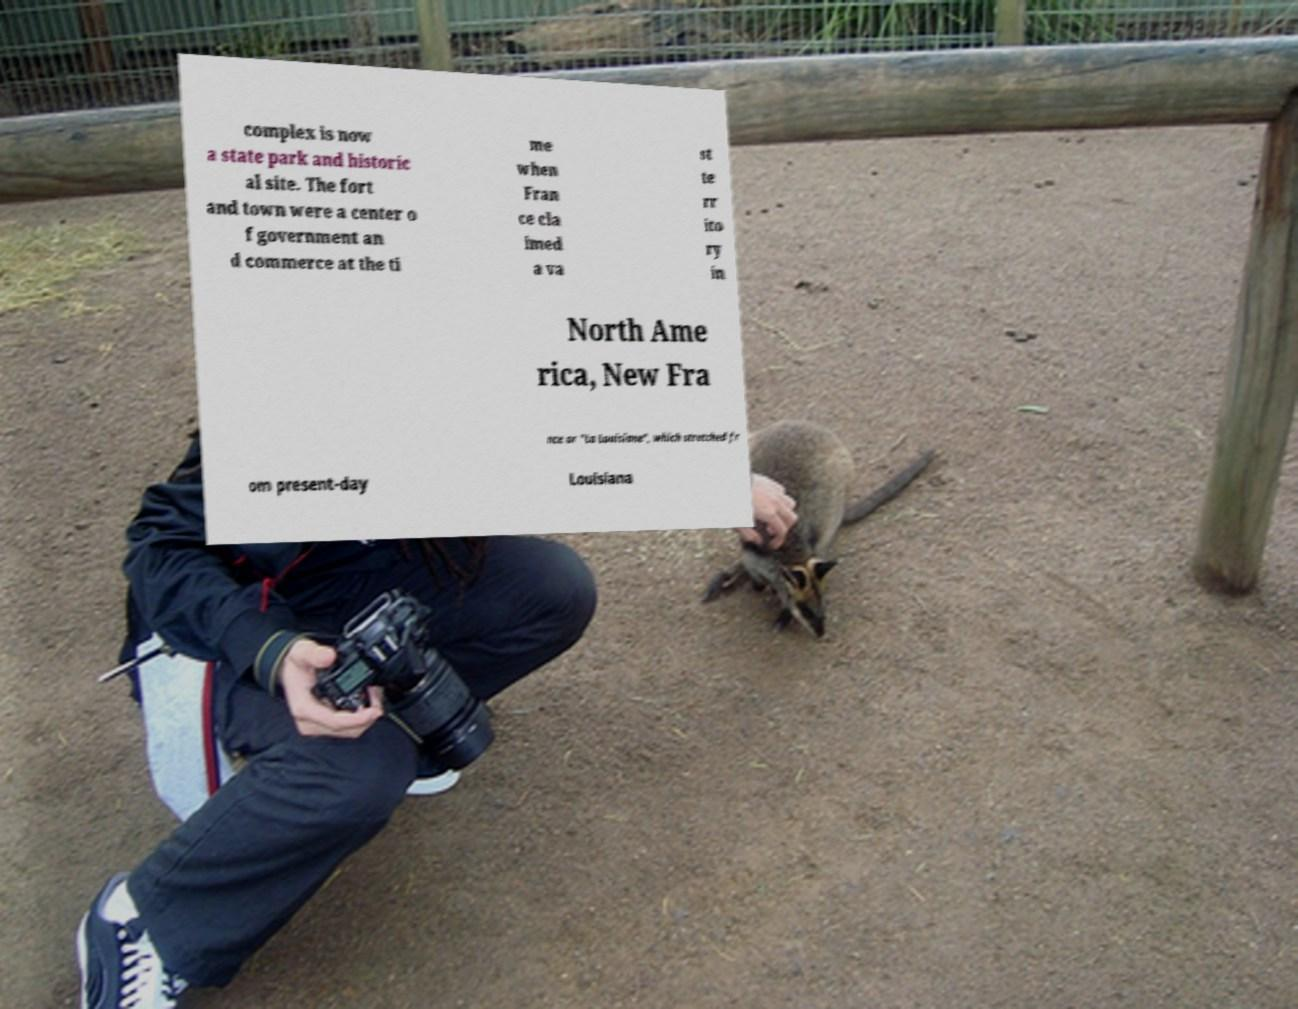Could you extract and type out the text from this image? complex is now a state park and historic al site. The fort and town were a center o f government an d commerce at the ti me when Fran ce cla imed a va st te rr ito ry in North Ame rica, New Fra nce or "La Louisiane", which stretched fr om present-day Louisiana 